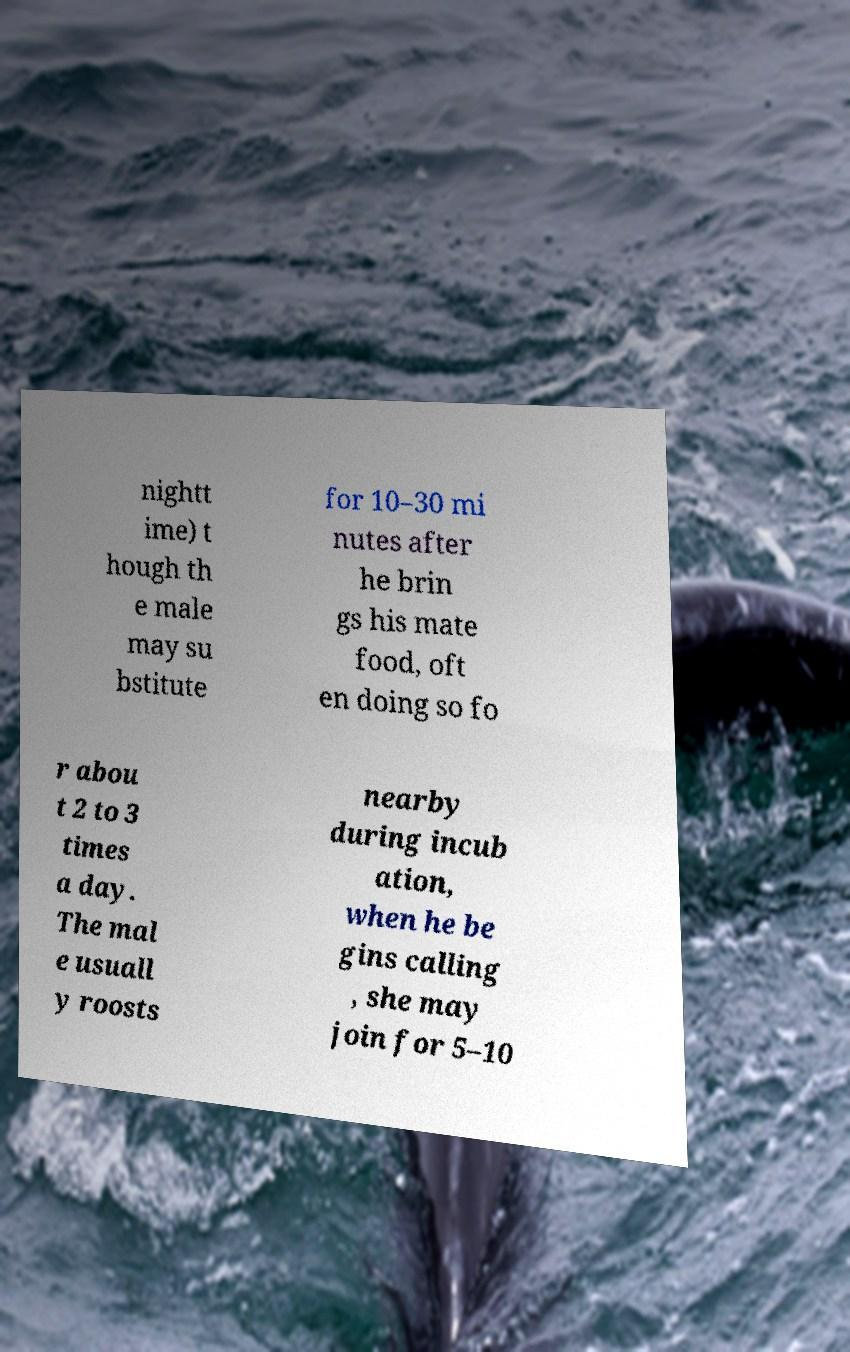I need the written content from this picture converted into text. Can you do that? nightt ime) t hough th e male may su bstitute for 10–30 mi nutes after he brin gs his mate food, oft en doing so fo r abou t 2 to 3 times a day. The mal e usuall y roosts nearby during incub ation, when he be gins calling , she may join for 5–10 